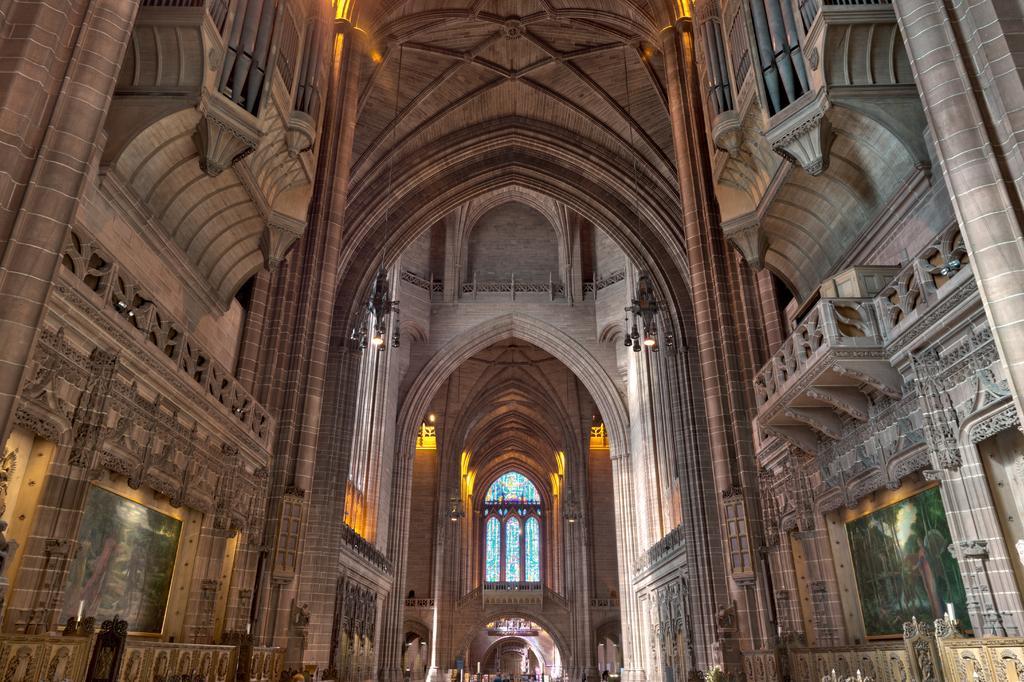Please provide a concise description of this image. This is a building with the window. 